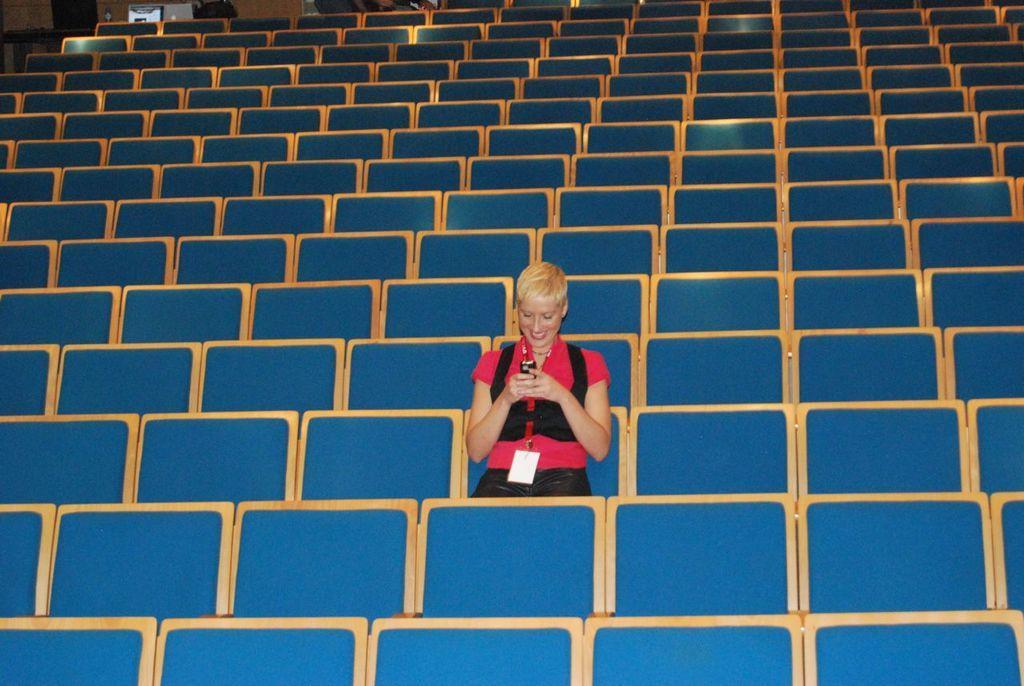Could you give a brief overview of what you see in this image? In this image we can see a woman wearing a red dress and id card is holding a mobile in her hand. In the background we can see a group of chairs and the door. 